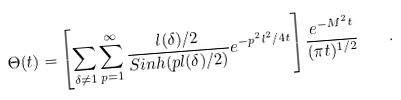Convert formula to latex. <formula><loc_0><loc_0><loc_500><loc_500>\Theta ( t ) = \left [ \sum _ { \delta \neq { 1 } } \sum _ { p = 1 } ^ { \infty } { \frac { l ( \delta ) / 2 } { S i n h ( p l ( \delta ) / 2 ) } } e ^ { - p ^ { 2 } l ^ { 2 } / 4 t } \right ] { \frac { e ^ { - M ^ { 2 } t } } { ( \pi t ) ^ { 1 / 2 } } } \quad .</formula> 